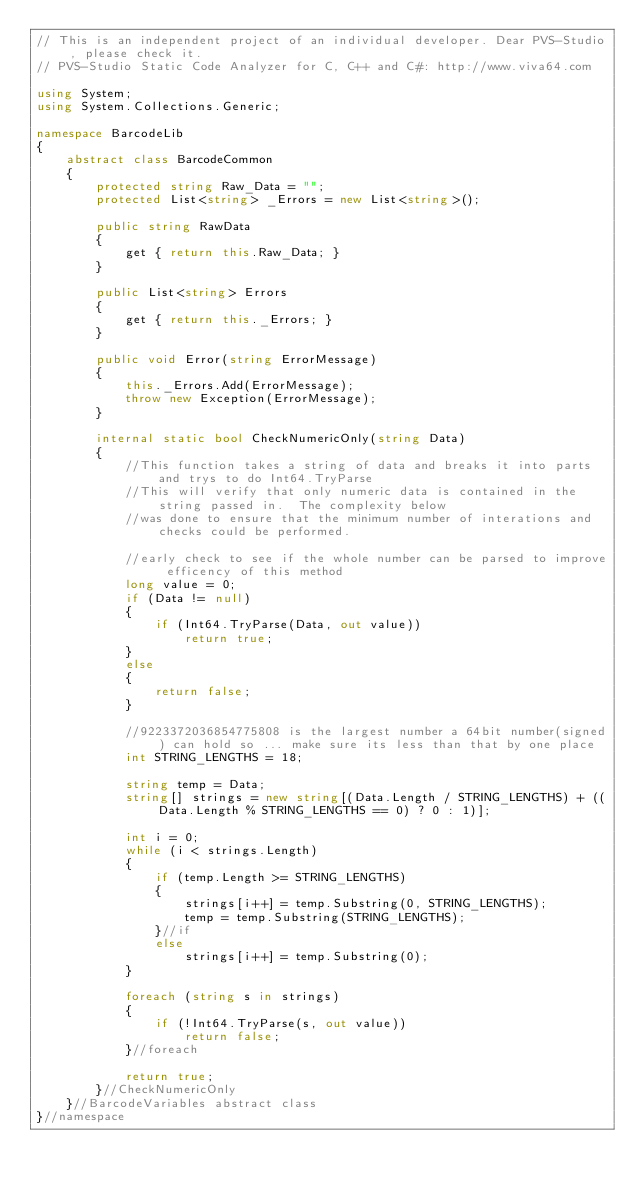<code> <loc_0><loc_0><loc_500><loc_500><_C#_>// This is an independent project of an individual developer. Dear PVS-Studio, please check it.
// PVS-Studio Static Code Analyzer for C, C++ and C#: http://www.viva64.com

using System;
using System.Collections.Generic;

namespace BarcodeLib
{
    abstract class BarcodeCommon
    {
        protected string Raw_Data = "";
        protected List<string> _Errors = new List<string>();

        public string RawData
        {
            get { return this.Raw_Data; }
        }

        public List<string> Errors
        {
            get { return this._Errors; }
        }

        public void Error(string ErrorMessage)
        {
            this._Errors.Add(ErrorMessage);
            throw new Exception(ErrorMessage);
        }

        internal static bool CheckNumericOnly(string Data)
        {
            //This function takes a string of data and breaks it into parts and trys to do Int64.TryParse
            //This will verify that only numeric data is contained in the string passed in.  The complexity below
            //was done to ensure that the minimum number of interations and checks could be performed.

            //early check to see if the whole number can be parsed to improve efficency of this method
            long value = 0;
            if (Data != null)
            {
                if (Int64.TryParse(Data, out value))
                    return true;
            }
            else
            {
                return false;
            }

            //9223372036854775808 is the largest number a 64bit number(signed) can hold so ... make sure its less than that by one place
            int STRING_LENGTHS = 18;

            string temp = Data;
            string[] strings = new string[(Data.Length / STRING_LENGTHS) + ((Data.Length % STRING_LENGTHS == 0) ? 0 : 1)];

            int i = 0;
            while (i < strings.Length)
            {
                if (temp.Length >= STRING_LENGTHS)
                {
                    strings[i++] = temp.Substring(0, STRING_LENGTHS);
                    temp = temp.Substring(STRING_LENGTHS);
                }//if
                else
                    strings[i++] = temp.Substring(0);
            }

            foreach (string s in strings)
            {
                if (!Int64.TryParse(s, out value))
                    return false;
            }//foreach

            return true;
        }//CheckNumericOnly
    }//BarcodeVariables abstract class
}//namespace
</code> 